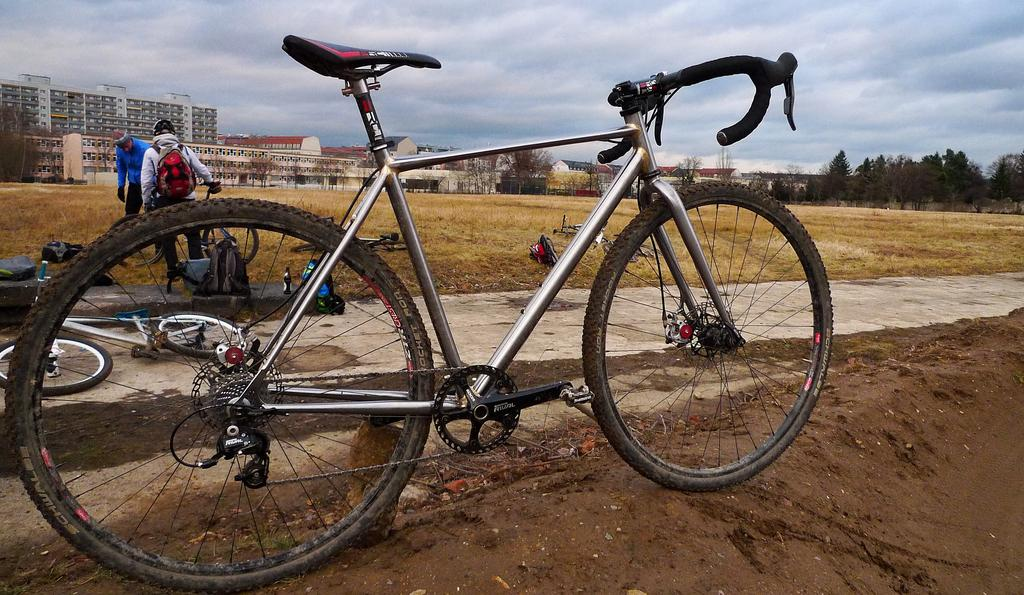What type of vehicles are in the image? There are bicycles in the image. How many people are in the image? There are two people in the image. What are the people carrying in the image? There are bags in the image. What type of natural elements can be seen in the image? There are trees in the image. What type of man-made structures can be seen in the image? There are buildings in the image. What else can be seen in the image besides the bicycles, people, bags, trees, and buildings? There are some other objects in the image. What is visible in the background of the image? The sky is visible in the background of the image. How many balls are being juggled by the people in the image? There are no balls present in the image; the people are not juggling. What date is marked on the calendar in the image? There is no calendar present in the image. 